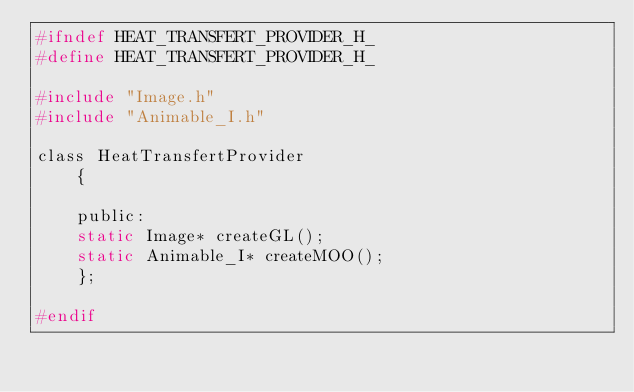Convert code to text. <code><loc_0><loc_0><loc_500><loc_500><_C_>#ifndef HEAT_TRANSFERT_PROVIDER_H_
#define HEAT_TRANSFERT_PROVIDER_H_

#include "Image.h"
#include "Animable_I.h"

class HeatTransfertProvider
    {

    public:
	static Image* createGL();
	static Animable_I* createMOO();
    };

#endif
</code> 